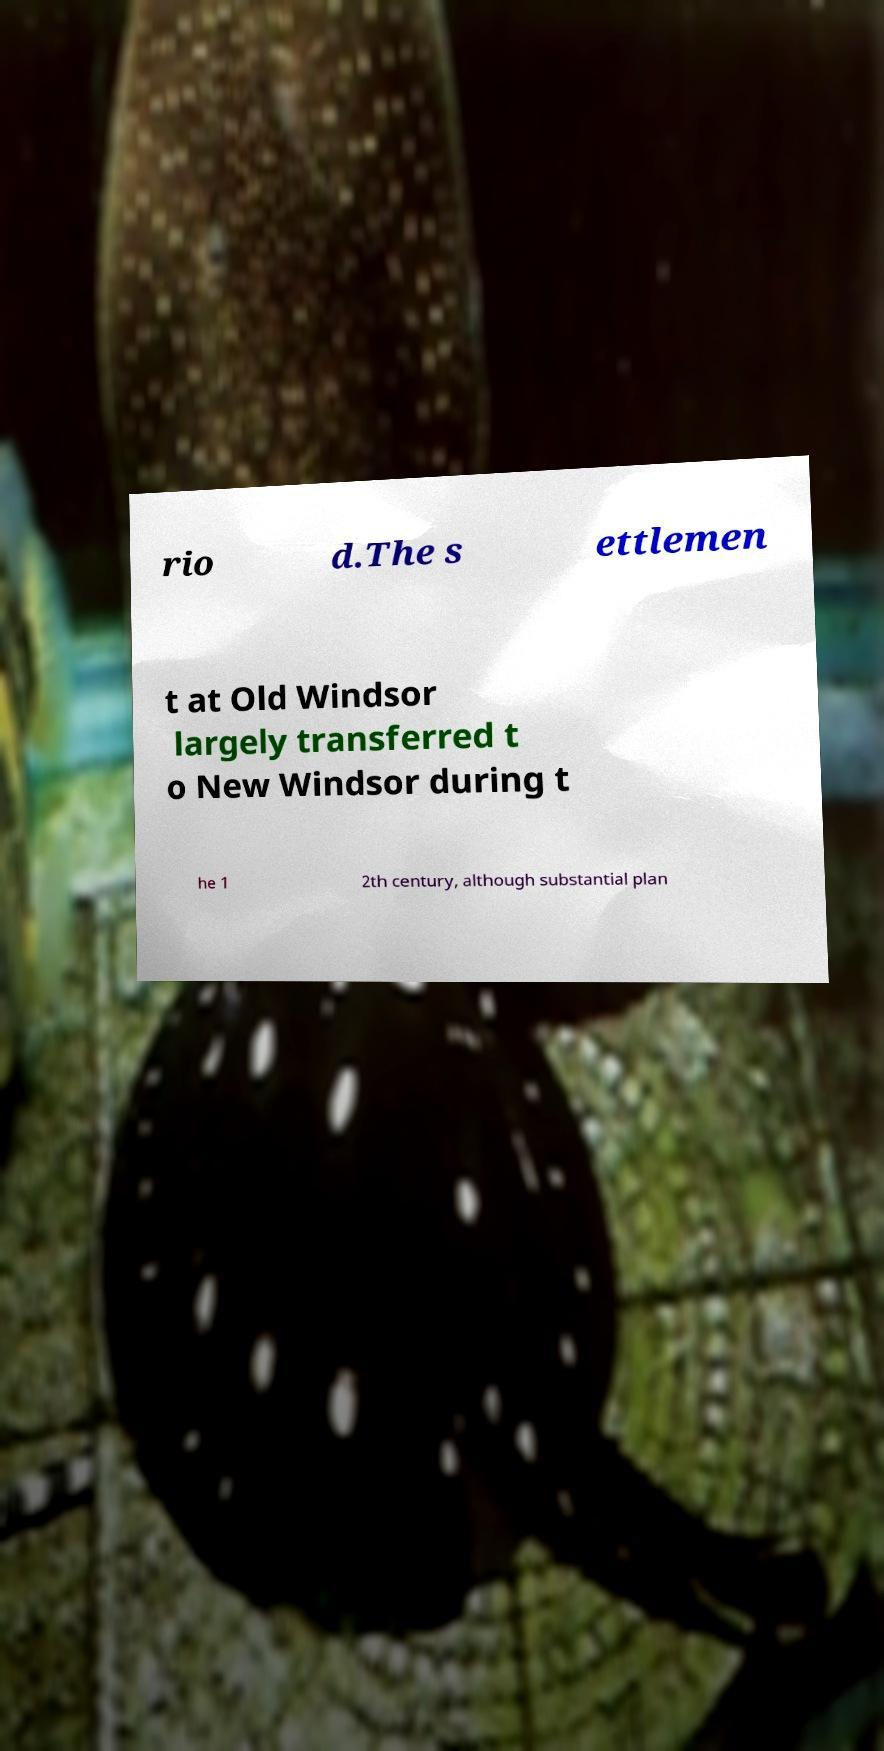Can you read and provide the text displayed in the image?This photo seems to have some interesting text. Can you extract and type it out for me? rio d.The s ettlemen t at Old Windsor largely transferred t o New Windsor during t he 1 2th century, although substantial plan 